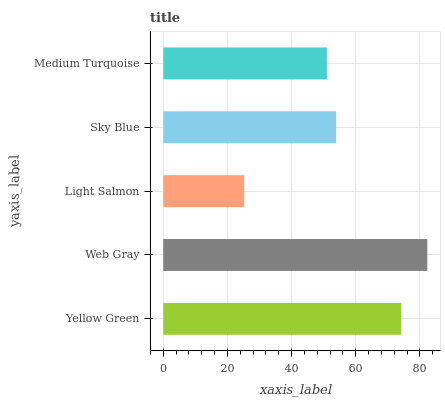Is Light Salmon the minimum?
Answer yes or no. Yes. Is Web Gray the maximum?
Answer yes or no. Yes. Is Web Gray the minimum?
Answer yes or no. No. Is Light Salmon the maximum?
Answer yes or no. No. Is Web Gray greater than Light Salmon?
Answer yes or no. Yes. Is Light Salmon less than Web Gray?
Answer yes or no. Yes. Is Light Salmon greater than Web Gray?
Answer yes or no. No. Is Web Gray less than Light Salmon?
Answer yes or no. No. Is Sky Blue the high median?
Answer yes or no. Yes. Is Sky Blue the low median?
Answer yes or no. Yes. Is Web Gray the high median?
Answer yes or no. No. Is Web Gray the low median?
Answer yes or no. No. 